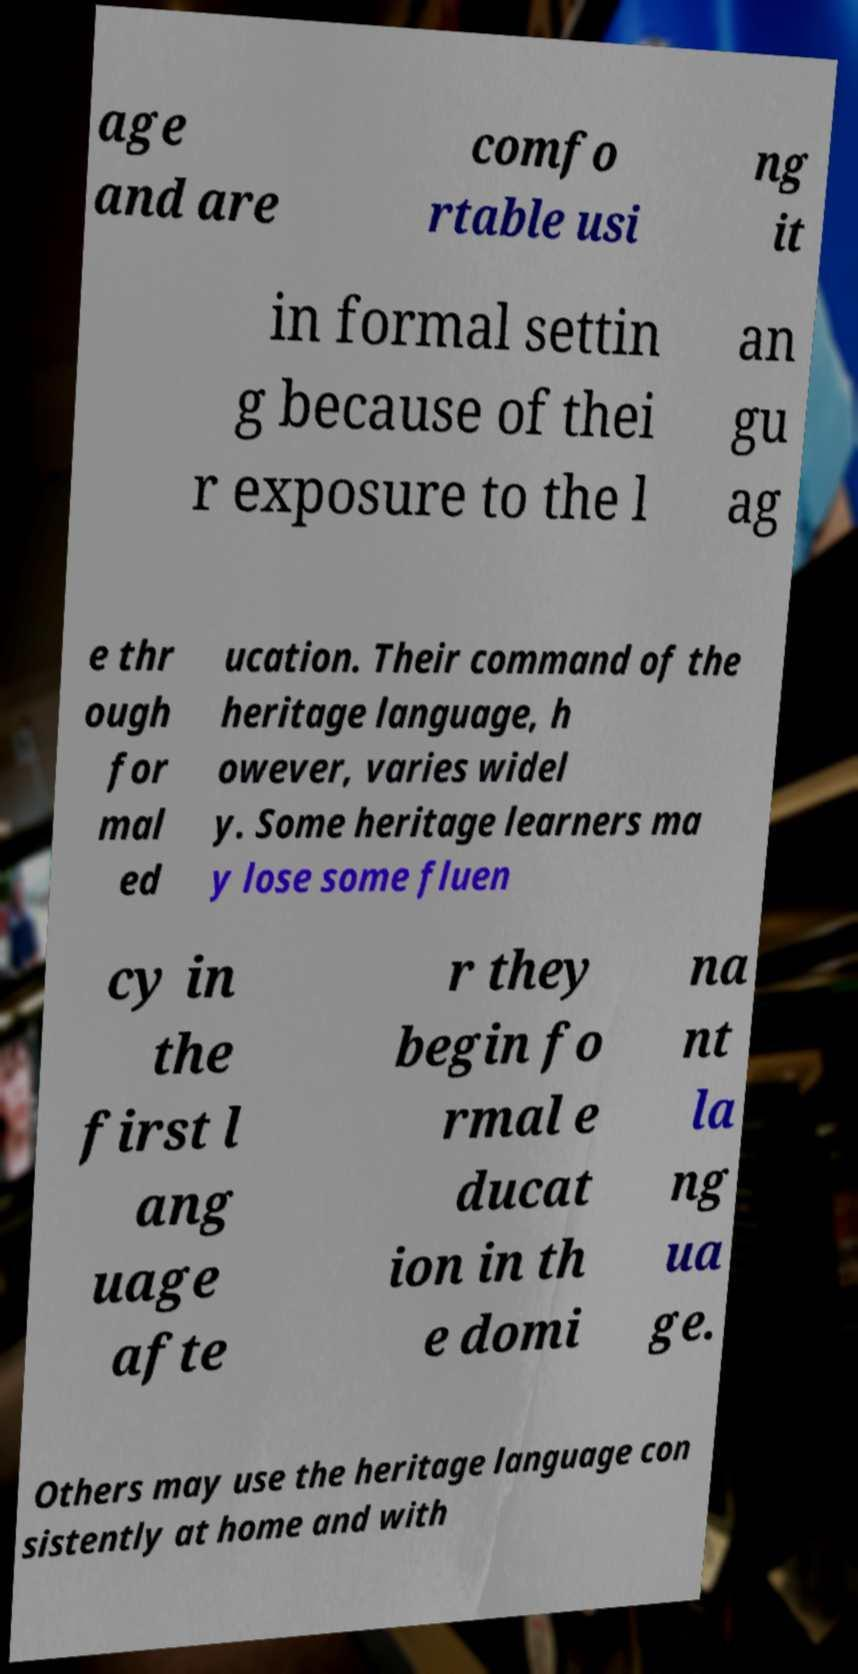Could you extract and type out the text from this image? age and are comfo rtable usi ng it in formal settin g because of thei r exposure to the l an gu ag e thr ough for mal ed ucation. Their command of the heritage language, h owever, varies widel y. Some heritage learners ma y lose some fluen cy in the first l ang uage afte r they begin fo rmal e ducat ion in th e domi na nt la ng ua ge. Others may use the heritage language con sistently at home and with 